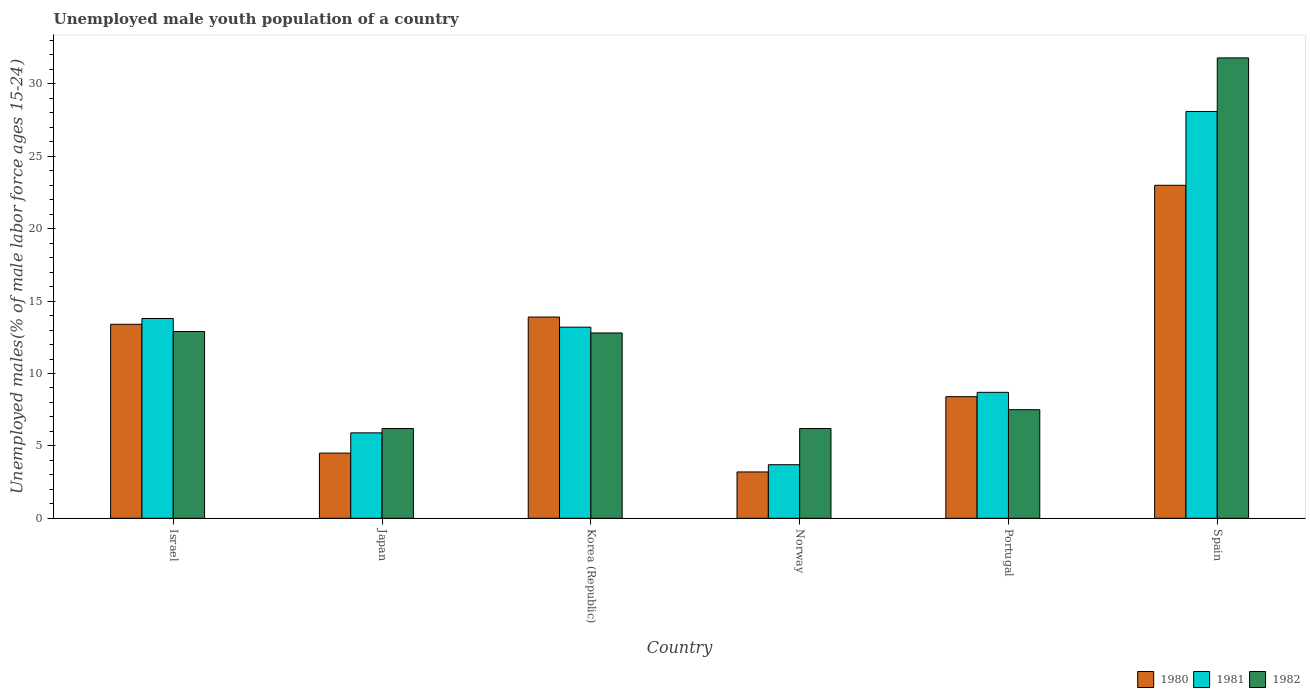How many groups of bars are there?
Provide a short and direct response. 6. Are the number of bars per tick equal to the number of legend labels?
Provide a short and direct response. Yes. Are the number of bars on each tick of the X-axis equal?
Make the answer very short. Yes. How many bars are there on the 4th tick from the left?
Your answer should be compact. 3. What is the label of the 1st group of bars from the left?
Provide a short and direct response. Israel. In how many cases, is the number of bars for a given country not equal to the number of legend labels?
Provide a short and direct response. 0. What is the percentage of unemployed male youth population in 1981 in Japan?
Make the answer very short. 5.9. Across all countries, what is the maximum percentage of unemployed male youth population in 1982?
Offer a very short reply. 31.8. Across all countries, what is the minimum percentage of unemployed male youth population in 1981?
Your answer should be very brief. 3.7. What is the total percentage of unemployed male youth population in 1981 in the graph?
Your answer should be very brief. 73.4. What is the difference between the percentage of unemployed male youth population in 1982 in Israel and that in Korea (Republic)?
Your answer should be compact. 0.1. What is the difference between the percentage of unemployed male youth population in 1982 in Spain and the percentage of unemployed male youth population in 1980 in Portugal?
Offer a very short reply. 23.4. What is the average percentage of unemployed male youth population in 1982 per country?
Ensure brevity in your answer.  12.9. What is the difference between the percentage of unemployed male youth population of/in 1982 and percentage of unemployed male youth population of/in 1980 in Portugal?
Give a very brief answer. -0.9. What is the ratio of the percentage of unemployed male youth population in 1980 in Israel to that in Norway?
Keep it short and to the point. 4.19. Is the percentage of unemployed male youth population in 1982 in Israel less than that in Portugal?
Your answer should be compact. No. Is the difference between the percentage of unemployed male youth population in 1982 in Korea (Republic) and Portugal greater than the difference between the percentage of unemployed male youth population in 1980 in Korea (Republic) and Portugal?
Your answer should be very brief. No. What is the difference between the highest and the lowest percentage of unemployed male youth population in 1980?
Make the answer very short. 19.8. In how many countries, is the percentage of unemployed male youth population in 1982 greater than the average percentage of unemployed male youth population in 1982 taken over all countries?
Offer a very short reply. 1. What does the 2nd bar from the right in Portugal represents?
Provide a succinct answer. 1981. Are all the bars in the graph horizontal?
Make the answer very short. No. Are the values on the major ticks of Y-axis written in scientific E-notation?
Provide a short and direct response. No. Does the graph contain grids?
Your answer should be compact. No. What is the title of the graph?
Ensure brevity in your answer.  Unemployed male youth population of a country. Does "1973" appear as one of the legend labels in the graph?
Provide a succinct answer. No. What is the label or title of the X-axis?
Your answer should be compact. Country. What is the label or title of the Y-axis?
Your answer should be very brief. Unemployed males(% of male labor force ages 15-24). What is the Unemployed males(% of male labor force ages 15-24) of 1980 in Israel?
Give a very brief answer. 13.4. What is the Unemployed males(% of male labor force ages 15-24) of 1981 in Israel?
Your answer should be compact. 13.8. What is the Unemployed males(% of male labor force ages 15-24) in 1982 in Israel?
Your answer should be very brief. 12.9. What is the Unemployed males(% of male labor force ages 15-24) in 1981 in Japan?
Your response must be concise. 5.9. What is the Unemployed males(% of male labor force ages 15-24) in 1982 in Japan?
Keep it short and to the point. 6.2. What is the Unemployed males(% of male labor force ages 15-24) of 1980 in Korea (Republic)?
Provide a short and direct response. 13.9. What is the Unemployed males(% of male labor force ages 15-24) of 1981 in Korea (Republic)?
Keep it short and to the point. 13.2. What is the Unemployed males(% of male labor force ages 15-24) of 1982 in Korea (Republic)?
Offer a very short reply. 12.8. What is the Unemployed males(% of male labor force ages 15-24) of 1980 in Norway?
Offer a very short reply. 3.2. What is the Unemployed males(% of male labor force ages 15-24) of 1981 in Norway?
Keep it short and to the point. 3.7. What is the Unemployed males(% of male labor force ages 15-24) of 1982 in Norway?
Your answer should be compact. 6.2. What is the Unemployed males(% of male labor force ages 15-24) in 1980 in Portugal?
Your response must be concise. 8.4. What is the Unemployed males(% of male labor force ages 15-24) in 1981 in Portugal?
Offer a terse response. 8.7. What is the Unemployed males(% of male labor force ages 15-24) in 1982 in Portugal?
Your response must be concise. 7.5. What is the Unemployed males(% of male labor force ages 15-24) of 1981 in Spain?
Give a very brief answer. 28.1. What is the Unemployed males(% of male labor force ages 15-24) in 1982 in Spain?
Give a very brief answer. 31.8. Across all countries, what is the maximum Unemployed males(% of male labor force ages 15-24) of 1981?
Your response must be concise. 28.1. Across all countries, what is the maximum Unemployed males(% of male labor force ages 15-24) of 1982?
Provide a succinct answer. 31.8. Across all countries, what is the minimum Unemployed males(% of male labor force ages 15-24) in 1980?
Provide a succinct answer. 3.2. Across all countries, what is the minimum Unemployed males(% of male labor force ages 15-24) of 1981?
Offer a terse response. 3.7. Across all countries, what is the minimum Unemployed males(% of male labor force ages 15-24) of 1982?
Give a very brief answer. 6.2. What is the total Unemployed males(% of male labor force ages 15-24) in 1980 in the graph?
Offer a very short reply. 66.4. What is the total Unemployed males(% of male labor force ages 15-24) in 1981 in the graph?
Offer a terse response. 73.4. What is the total Unemployed males(% of male labor force ages 15-24) in 1982 in the graph?
Your response must be concise. 77.4. What is the difference between the Unemployed males(% of male labor force ages 15-24) of 1981 in Israel and that in Japan?
Your answer should be compact. 7.9. What is the difference between the Unemployed males(% of male labor force ages 15-24) of 1982 in Israel and that in Japan?
Offer a terse response. 6.7. What is the difference between the Unemployed males(% of male labor force ages 15-24) in 1980 in Israel and that in Norway?
Make the answer very short. 10.2. What is the difference between the Unemployed males(% of male labor force ages 15-24) in 1982 in Israel and that in Norway?
Make the answer very short. 6.7. What is the difference between the Unemployed males(% of male labor force ages 15-24) in 1980 in Israel and that in Portugal?
Make the answer very short. 5. What is the difference between the Unemployed males(% of male labor force ages 15-24) in 1981 in Israel and that in Portugal?
Provide a short and direct response. 5.1. What is the difference between the Unemployed males(% of male labor force ages 15-24) in 1982 in Israel and that in Portugal?
Your response must be concise. 5.4. What is the difference between the Unemployed males(% of male labor force ages 15-24) of 1980 in Israel and that in Spain?
Your response must be concise. -9.6. What is the difference between the Unemployed males(% of male labor force ages 15-24) of 1981 in Israel and that in Spain?
Make the answer very short. -14.3. What is the difference between the Unemployed males(% of male labor force ages 15-24) of 1982 in Israel and that in Spain?
Offer a very short reply. -18.9. What is the difference between the Unemployed males(% of male labor force ages 15-24) in 1980 in Japan and that in Korea (Republic)?
Offer a terse response. -9.4. What is the difference between the Unemployed males(% of male labor force ages 15-24) of 1981 in Japan and that in Korea (Republic)?
Offer a terse response. -7.3. What is the difference between the Unemployed males(% of male labor force ages 15-24) in 1980 in Japan and that in Norway?
Offer a very short reply. 1.3. What is the difference between the Unemployed males(% of male labor force ages 15-24) in 1980 in Japan and that in Portugal?
Provide a short and direct response. -3.9. What is the difference between the Unemployed males(% of male labor force ages 15-24) of 1982 in Japan and that in Portugal?
Make the answer very short. -1.3. What is the difference between the Unemployed males(% of male labor force ages 15-24) of 1980 in Japan and that in Spain?
Make the answer very short. -18.5. What is the difference between the Unemployed males(% of male labor force ages 15-24) in 1981 in Japan and that in Spain?
Make the answer very short. -22.2. What is the difference between the Unemployed males(% of male labor force ages 15-24) in 1982 in Japan and that in Spain?
Make the answer very short. -25.6. What is the difference between the Unemployed males(% of male labor force ages 15-24) of 1981 in Korea (Republic) and that in Norway?
Your response must be concise. 9.5. What is the difference between the Unemployed males(% of male labor force ages 15-24) of 1982 in Korea (Republic) and that in Norway?
Your response must be concise. 6.6. What is the difference between the Unemployed males(% of male labor force ages 15-24) of 1980 in Korea (Republic) and that in Portugal?
Provide a short and direct response. 5.5. What is the difference between the Unemployed males(% of male labor force ages 15-24) in 1981 in Korea (Republic) and that in Portugal?
Make the answer very short. 4.5. What is the difference between the Unemployed males(% of male labor force ages 15-24) in 1982 in Korea (Republic) and that in Portugal?
Give a very brief answer. 5.3. What is the difference between the Unemployed males(% of male labor force ages 15-24) of 1980 in Korea (Republic) and that in Spain?
Provide a short and direct response. -9.1. What is the difference between the Unemployed males(% of male labor force ages 15-24) in 1981 in Korea (Republic) and that in Spain?
Give a very brief answer. -14.9. What is the difference between the Unemployed males(% of male labor force ages 15-24) in 1982 in Korea (Republic) and that in Spain?
Your answer should be very brief. -19. What is the difference between the Unemployed males(% of male labor force ages 15-24) in 1981 in Norway and that in Portugal?
Make the answer very short. -5. What is the difference between the Unemployed males(% of male labor force ages 15-24) of 1980 in Norway and that in Spain?
Offer a terse response. -19.8. What is the difference between the Unemployed males(% of male labor force ages 15-24) of 1981 in Norway and that in Spain?
Offer a very short reply. -24.4. What is the difference between the Unemployed males(% of male labor force ages 15-24) of 1982 in Norway and that in Spain?
Keep it short and to the point. -25.6. What is the difference between the Unemployed males(% of male labor force ages 15-24) in 1980 in Portugal and that in Spain?
Your answer should be very brief. -14.6. What is the difference between the Unemployed males(% of male labor force ages 15-24) of 1981 in Portugal and that in Spain?
Make the answer very short. -19.4. What is the difference between the Unemployed males(% of male labor force ages 15-24) of 1982 in Portugal and that in Spain?
Provide a succinct answer. -24.3. What is the difference between the Unemployed males(% of male labor force ages 15-24) of 1980 in Israel and the Unemployed males(% of male labor force ages 15-24) of 1981 in Japan?
Keep it short and to the point. 7.5. What is the difference between the Unemployed males(% of male labor force ages 15-24) of 1981 in Israel and the Unemployed males(% of male labor force ages 15-24) of 1982 in Japan?
Your answer should be very brief. 7.6. What is the difference between the Unemployed males(% of male labor force ages 15-24) in 1980 in Israel and the Unemployed males(% of male labor force ages 15-24) in 1981 in Korea (Republic)?
Offer a terse response. 0.2. What is the difference between the Unemployed males(% of male labor force ages 15-24) in 1980 in Israel and the Unemployed males(% of male labor force ages 15-24) in 1982 in Korea (Republic)?
Keep it short and to the point. 0.6. What is the difference between the Unemployed males(% of male labor force ages 15-24) of 1980 in Israel and the Unemployed males(% of male labor force ages 15-24) of 1981 in Norway?
Offer a very short reply. 9.7. What is the difference between the Unemployed males(% of male labor force ages 15-24) in 1980 in Israel and the Unemployed males(% of male labor force ages 15-24) in 1981 in Spain?
Ensure brevity in your answer.  -14.7. What is the difference between the Unemployed males(% of male labor force ages 15-24) in 1980 in Israel and the Unemployed males(% of male labor force ages 15-24) in 1982 in Spain?
Provide a short and direct response. -18.4. What is the difference between the Unemployed males(% of male labor force ages 15-24) in 1981 in Israel and the Unemployed males(% of male labor force ages 15-24) in 1982 in Spain?
Offer a terse response. -18. What is the difference between the Unemployed males(% of male labor force ages 15-24) in 1980 in Japan and the Unemployed males(% of male labor force ages 15-24) in 1981 in Korea (Republic)?
Ensure brevity in your answer.  -8.7. What is the difference between the Unemployed males(% of male labor force ages 15-24) of 1980 in Japan and the Unemployed males(% of male labor force ages 15-24) of 1982 in Korea (Republic)?
Offer a very short reply. -8.3. What is the difference between the Unemployed males(% of male labor force ages 15-24) of 1981 in Japan and the Unemployed males(% of male labor force ages 15-24) of 1982 in Korea (Republic)?
Keep it short and to the point. -6.9. What is the difference between the Unemployed males(% of male labor force ages 15-24) in 1980 in Japan and the Unemployed males(% of male labor force ages 15-24) in 1981 in Portugal?
Your answer should be compact. -4.2. What is the difference between the Unemployed males(% of male labor force ages 15-24) of 1981 in Japan and the Unemployed males(% of male labor force ages 15-24) of 1982 in Portugal?
Your answer should be very brief. -1.6. What is the difference between the Unemployed males(% of male labor force ages 15-24) in 1980 in Japan and the Unemployed males(% of male labor force ages 15-24) in 1981 in Spain?
Keep it short and to the point. -23.6. What is the difference between the Unemployed males(% of male labor force ages 15-24) in 1980 in Japan and the Unemployed males(% of male labor force ages 15-24) in 1982 in Spain?
Ensure brevity in your answer.  -27.3. What is the difference between the Unemployed males(% of male labor force ages 15-24) of 1981 in Japan and the Unemployed males(% of male labor force ages 15-24) of 1982 in Spain?
Provide a short and direct response. -25.9. What is the difference between the Unemployed males(% of male labor force ages 15-24) in 1980 in Korea (Republic) and the Unemployed males(% of male labor force ages 15-24) in 1981 in Norway?
Your answer should be compact. 10.2. What is the difference between the Unemployed males(% of male labor force ages 15-24) in 1980 in Korea (Republic) and the Unemployed males(% of male labor force ages 15-24) in 1982 in Norway?
Make the answer very short. 7.7. What is the difference between the Unemployed males(% of male labor force ages 15-24) of 1980 in Korea (Republic) and the Unemployed males(% of male labor force ages 15-24) of 1982 in Portugal?
Provide a short and direct response. 6.4. What is the difference between the Unemployed males(% of male labor force ages 15-24) of 1980 in Korea (Republic) and the Unemployed males(% of male labor force ages 15-24) of 1982 in Spain?
Give a very brief answer. -17.9. What is the difference between the Unemployed males(% of male labor force ages 15-24) in 1981 in Korea (Republic) and the Unemployed males(% of male labor force ages 15-24) in 1982 in Spain?
Offer a very short reply. -18.6. What is the difference between the Unemployed males(% of male labor force ages 15-24) of 1980 in Norway and the Unemployed males(% of male labor force ages 15-24) of 1981 in Portugal?
Make the answer very short. -5.5. What is the difference between the Unemployed males(% of male labor force ages 15-24) of 1980 in Norway and the Unemployed males(% of male labor force ages 15-24) of 1982 in Portugal?
Provide a succinct answer. -4.3. What is the difference between the Unemployed males(% of male labor force ages 15-24) of 1980 in Norway and the Unemployed males(% of male labor force ages 15-24) of 1981 in Spain?
Offer a very short reply. -24.9. What is the difference between the Unemployed males(% of male labor force ages 15-24) in 1980 in Norway and the Unemployed males(% of male labor force ages 15-24) in 1982 in Spain?
Your answer should be compact. -28.6. What is the difference between the Unemployed males(% of male labor force ages 15-24) in 1981 in Norway and the Unemployed males(% of male labor force ages 15-24) in 1982 in Spain?
Provide a short and direct response. -28.1. What is the difference between the Unemployed males(% of male labor force ages 15-24) in 1980 in Portugal and the Unemployed males(% of male labor force ages 15-24) in 1981 in Spain?
Offer a very short reply. -19.7. What is the difference between the Unemployed males(% of male labor force ages 15-24) of 1980 in Portugal and the Unemployed males(% of male labor force ages 15-24) of 1982 in Spain?
Make the answer very short. -23.4. What is the difference between the Unemployed males(% of male labor force ages 15-24) in 1981 in Portugal and the Unemployed males(% of male labor force ages 15-24) in 1982 in Spain?
Make the answer very short. -23.1. What is the average Unemployed males(% of male labor force ages 15-24) in 1980 per country?
Keep it short and to the point. 11.07. What is the average Unemployed males(% of male labor force ages 15-24) of 1981 per country?
Your answer should be very brief. 12.23. What is the difference between the Unemployed males(% of male labor force ages 15-24) of 1980 and Unemployed males(% of male labor force ages 15-24) of 1982 in Israel?
Provide a short and direct response. 0.5. What is the difference between the Unemployed males(% of male labor force ages 15-24) in 1980 and Unemployed males(% of male labor force ages 15-24) in 1982 in Japan?
Your answer should be compact. -1.7. What is the difference between the Unemployed males(% of male labor force ages 15-24) in 1981 and Unemployed males(% of male labor force ages 15-24) in 1982 in Japan?
Give a very brief answer. -0.3. What is the difference between the Unemployed males(% of male labor force ages 15-24) of 1981 and Unemployed males(% of male labor force ages 15-24) of 1982 in Korea (Republic)?
Your response must be concise. 0.4. What is the difference between the Unemployed males(% of male labor force ages 15-24) in 1980 and Unemployed males(% of male labor force ages 15-24) in 1981 in Norway?
Provide a short and direct response. -0.5. What is the difference between the Unemployed males(% of male labor force ages 15-24) in 1980 and Unemployed males(% of male labor force ages 15-24) in 1981 in Portugal?
Ensure brevity in your answer.  -0.3. What is the difference between the Unemployed males(% of male labor force ages 15-24) of 1980 and Unemployed males(% of male labor force ages 15-24) of 1982 in Spain?
Provide a succinct answer. -8.8. What is the ratio of the Unemployed males(% of male labor force ages 15-24) in 1980 in Israel to that in Japan?
Provide a short and direct response. 2.98. What is the ratio of the Unemployed males(% of male labor force ages 15-24) in 1981 in Israel to that in Japan?
Give a very brief answer. 2.34. What is the ratio of the Unemployed males(% of male labor force ages 15-24) in 1982 in Israel to that in Japan?
Your response must be concise. 2.08. What is the ratio of the Unemployed males(% of male labor force ages 15-24) of 1980 in Israel to that in Korea (Republic)?
Keep it short and to the point. 0.96. What is the ratio of the Unemployed males(% of male labor force ages 15-24) of 1981 in Israel to that in Korea (Republic)?
Provide a succinct answer. 1.05. What is the ratio of the Unemployed males(% of male labor force ages 15-24) in 1980 in Israel to that in Norway?
Ensure brevity in your answer.  4.19. What is the ratio of the Unemployed males(% of male labor force ages 15-24) in 1981 in Israel to that in Norway?
Give a very brief answer. 3.73. What is the ratio of the Unemployed males(% of male labor force ages 15-24) in 1982 in Israel to that in Norway?
Offer a terse response. 2.08. What is the ratio of the Unemployed males(% of male labor force ages 15-24) of 1980 in Israel to that in Portugal?
Make the answer very short. 1.6. What is the ratio of the Unemployed males(% of male labor force ages 15-24) of 1981 in Israel to that in Portugal?
Offer a terse response. 1.59. What is the ratio of the Unemployed males(% of male labor force ages 15-24) of 1982 in Israel to that in Portugal?
Offer a very short reply. 1.72. What is the ratio of the Unemployed males(% of male labor force ages 15-24) in 1980 in Israel to that in Spain?
Ensure brevity in your answer.  0.58. What is the ratio of the Unemployed males(% of male labor force ages 15-24) of 1981 in Israel to that in Spain?
Your answer should be compact. 0.49. What is the ratio of the Unemployed males(% of male labor force ages 15-24) of 1982 in Israel to that in Spain?
Offer a very short reply. 0.41. What is the ratio of the Unemployed males(% of male labor force ages 15-24) of 1980 in Japan to that in Korea (Republic)?
Keep it short and to the point. 0.32. What is the ratio of the Unemployed males(% of male labor force ages 15-24) in 1981 in Japan to that in Korea (Republic)?
Your answer should be compact. 0.45. What is the ratio of the Unemployed males(% of male labor force ages 15-24) of 1982 in Japan to that in Korea (Republic)?
Provide a short and direct response. 0.48. What is the ratio of the Unemployed males(% of male labor force ages 15-24) in 1980 in Japan to that in Norway?
Make the answer very short. 1.41. What is the ratio of the Unemployed males(% of male labor force ages 15-24) in 1981 in Japan to that in Norway?
Give a very brief answer. 1.59. What is the ratio of the Unemployed males(% of male labor force ages 15-24) of 1982 in Japan to that in Norway?
Give a very brief answer. 1. What is the ratio of the Unemployed males(% of male labor force ages 15-24) of 1980 in Japan to that in Portugal?
Keep it short and to the point. 0.54. What is the ratio of the Unemployed males(% of male labor force ages 15-24) of 1981 in Japan to that in Portugal?
Your answer should be very brief. 0.68. What is the ratio of the Unemployed males(% of male labor force ages 15-24) in 1982 in Japan to that in Portugal?
Your response must be concise. 0.83. What is the ratio of the Unemployed males(% of male labor force ages 15-24) in 1980 in Japan to that in Spain?
Keep it short and to the point. 0.2. What is the ratio of the Unemployed males(% of male labor force ages 15-24) of 1981 in Japan to that in Spain?
Offer a terse response. 0.21. What is the ratio of the Unemployed males(% of male labor force ages 15-24) in 1982 in Japan to that in Spain?
Ensure brevity in your answer.  0.2. What is the ratio of the Unemployed males(% of male labor force ages 15-24) in 1980 in Korea (Republic) to that in Norway?
Provide a succinct answer. 4.34. What is the ratio of the Unemployed males(% of male labor force ages 15-24) of 1981 in Korea (Republic) to that in Norway?
Provide a succinct answer. 3.57. What is the ratio of the Unemployed males(% of male labor force ages 15-24) of 1982 in Korea (Republic) to that in Norway?
Your answer should be compact. 2.06. What is the ratio of the Unemployed males(% of male labor force ages 15-24) in 1980 in Korea (Republic) to that in Portugal?
Your answer should be compact. 1.65. What is the ratio of the Unemployed males(% of male labor force ages 15-24) in 1981 in Korea (Republic) to that in Portugal?
Keep it short and to the point. 1.52. What is the ratio of the Unemployed males(% of male labor force ages 15-24) of 1982 in Korea (Republic) to that in Portugal?
Your answer should be very brief. 1.71. What is the ratio of the Unemployed males(% of male labor force ages 15-24) in 1980 in Korea (Republic) to that in Spain?
Give a very brief answer. 0.6. What is the ratio of the Unemployed males(% of male labor force ages 15-24) of 1981 in Korea (Republic) to that in Spain?
Your answer should be compact. 0.47. What is the ratio of the Unemployed males(% of male labor force ages 15-24) of 1982 in Korea (Republic) to that in Spain?
Your answer should be very brief. 0.4. What is the ratio of the Unemployed males(% of male labor force ages 15-24) in 1980 in Norway to that in Portugal?
Your response must be concise. 0.38. What is the ratio of the Unemployed males(% of male labor force ages 15-24) of 1981 in Norway to that in Portugal?
Offer a terse response. 0.43. What is the ratio of the Unemployed males(% of male labor force ages 15-24) of 1982 in Norway to that in Portugal?
Keep it short and to the point. 0.83. What is the ratio of the Unemployed males(% of male labor force ages 15-24) in 1980 in Norway to that in Spain?
Ensure brevity in your answer.  0.14. What is the ratio of the Unemployed males(% of male labor force ages 15-24) in 1981 in Norway to that in Spain?
Provide a short and direct response. 0.13. What is the ratio of the Unemployed males(% of male labor force ages 15-24) in 1982 in Norway to that in Spain?
Make the answer very short. 0.2. What is the ratio of the Unemployed males(% of male labor force ages 15-24) in 1980 in Portugal to that in Spain?
Ensure brevity in your answer.  0.37. What is the ratio of the Unemployed males(% of male labor force ages 15-24) of 1981 in Portugal to that in Spain?
Your answer should be very brief. 0.31. What is the ratio of the Unemployed males(% of male labor force ages 15-24) of 1982 in Portugal to that in Spain?
Provide a short and direct response. 0.24. What is the difference between the highest and the second highest Unemployed males(% of male labor force ages 15-24) of 1981?
Offer a very short reply. 14.3. What is the difference between the highest and the second highest Unemployed males(% of male labor force ages 15-24) in 1982?
Make the answer very short. 18.9. What is the difference between the highest and the lowest Unemployed males(% of male labor force ages 15-24) in 1980?
Ensure brevity in your answer.  19.8. What is the difference between the highest and the lowest Unemployed males(% of male labor force ages 15-24) in 1981?
Offer a very short reply. 24.4. What is the difference between the highest and the lowest Unemployed males(% of male labor force ages 15-24) of 1982?
Provide a short and direct response. 25.6. 